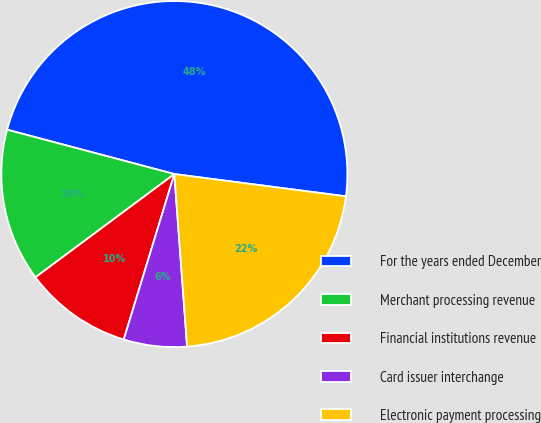Convert chart. <chart><loc_0><loc_0><loc_500><loc_500><pie_chart><fcel>For the years ended December<fcel>Merchant processing revenue<fcel>Financial institutions revenue<fcel>Card issuer interchange<fcel>Electronic payment processing<nl><fcel>47.93%<fcel>14.3%<fcel>10.1%<fcel>5.9%<fcel>21.77%<nl></chart> 